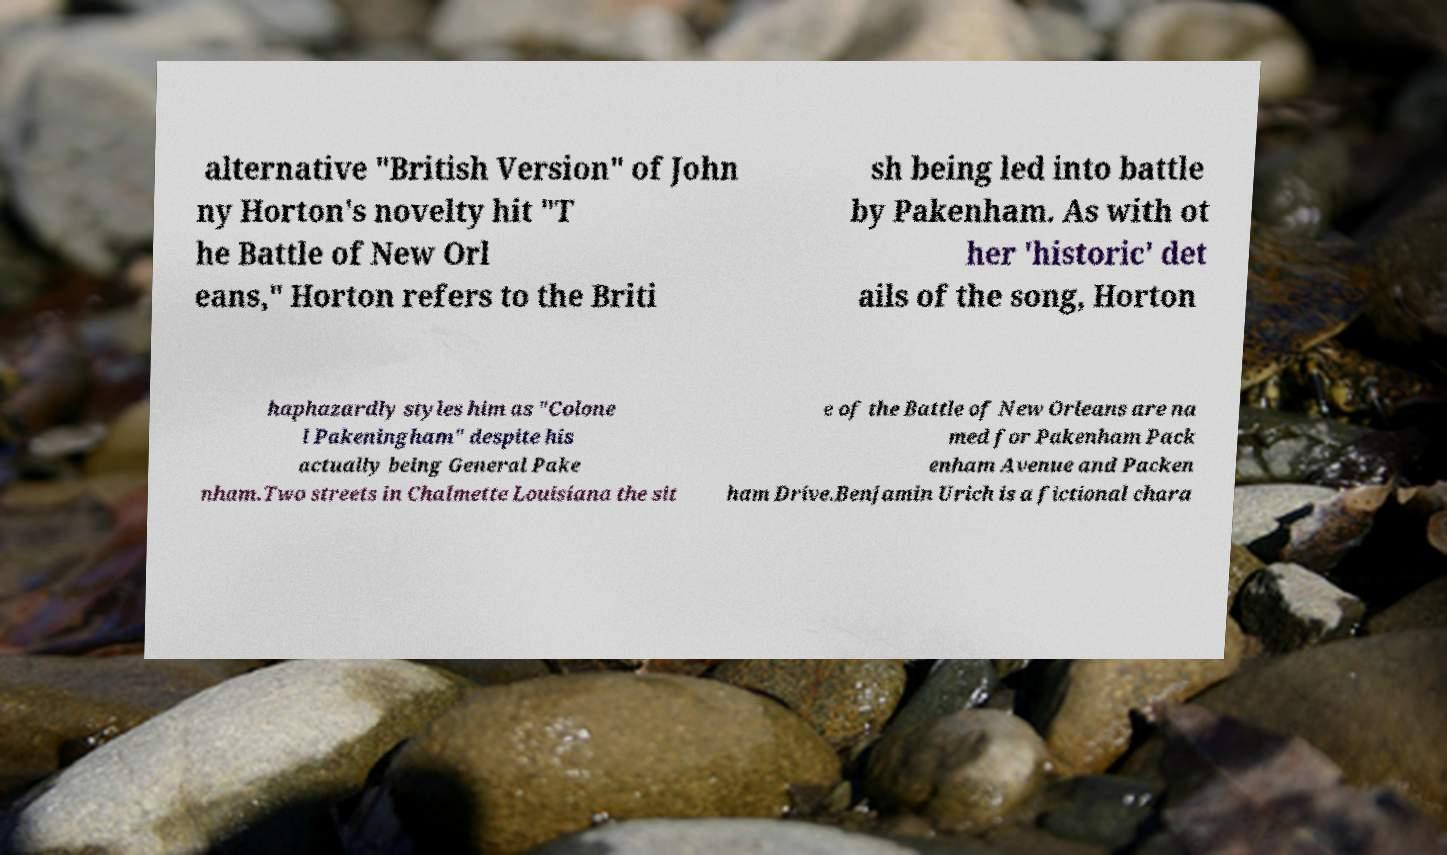What messages or text are displayed in this image? I need them in a readable, typed format. alternative "British Version" of John ny Horton's novelty hit "T he Battle of New Orl eans," Horton refers to the Briti sh being led into battle by Pakenham. As with ot her 'historic' det ails of the song, Horton haphazardly styles him as "Colone l Pakeningham" despite his actually being General Pake nham.Two streets in Chalmette Louisiana the sit e of the Battle of New Orleans are na med for Pakenham Pack enham Avenue and Packen ham Drive.Benjamin Urich is a fictional chara 